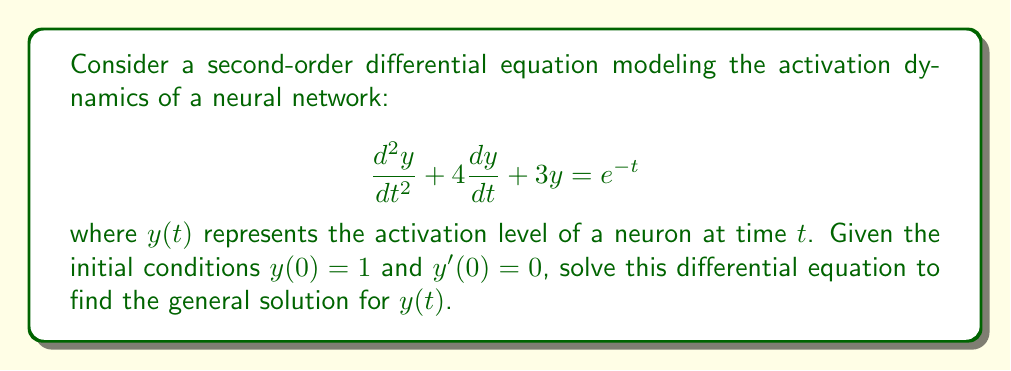Show me your answer to this math problem. To solve this second-order linear differential equation, we'll follow these steps:

1) First, we identify the homogeneous and particular solutions:
   The homogeneous equation is: $\frac{d^2y}{dt^2} + 4\frac{dy}{dt} + 3y = 0$
   The particular solution will be due to the right-hand side: $e^{-t}$

2) For the homogeneous solution:
   Characteristic equation: $r^2 + 4r + 3 = 0$
   Solving this: $(r+1)(r+3) = 0$
   Roots: $r_1 = -1$, $r_2 = -3$
   
   Therefore, the homogeneous solution is:
   $y_h(t) = c_1e^{-t} + c_2e^{-3t}$

3) For the particular solution:
   We guess a solution of the form $y_p(t) = Ae^{-t}$
   Substituting this into the original equation:
   $Ae^{-t} + 4(-A)e^{-t} + 3Ae^{-t} = e^{-t}$
   $Ae^{-t} - 4Ae^{-t} + 3Ae^{-t} = e^{-t}$
   $0 = e^{-t}$
   
   This means our guess was incorrect. We need to modify our guess:
   $y_p(t) = Ate^{-t}$
   
   Substituting this new guess:
   $(Ae^{-t} - Ate^{-t}) + 4(Ae^{-t} - Ate^{-t}) + 3Ate^{-t} = e^{-t}$
   $Ae^{-t} - Ate^{-t} + 4Ae^{-t} - 4Ate^{-t} + 3Ate^{-t} = e^{-t}$
   $Ae^{-t} + 4Ae^{-t} - 2Ate^{-t} = e^{-t}$
   $(5A - 2At)e^{-t} = e^{-t}$
   
   Equating coefficients: $5A = 1$ and $-2A = 0$
   Solving these: $A = \frac{1}{5}$

   Therefore, the particular solution is:
   $y_p(t) = \frac{1}{5}te^{-t}$

4) The general solution is the sum of homogeneous and particular solutions:
   $y(t) = c_1e^{-t} + c_2e^{-3t} + \frac{1}{5}te^{-t}$

5) To find $c_1$ and $c_2$, we use the initial conditions:
   $y(0) = 1$: $c_1 + c_2 = 1$
   $y'(0) = 0$: $-c_1 - 3c_2 + \frac{1}{5} = 0$

   Solving these equations:
   $c_1 = \frac{6}{5}$, $c_2 = -\frac{1}{5}$

Therefore, the final solution is:
$$y(t) = \frac{6}{5}e^{-t} - \frac{1}{5}e^{-3t} + \frac{1}{5}te^{-t}$$
Answer: $$y(t) = \frac{6}{5}e^{-t} - \frac{1}{5}e^{-3t} + \frac{1}{5}te^{-t}$$ 